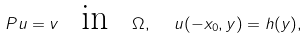<formula> <loc_0><loc_0><loc_500><loc_500>P u = v \text { } \text { in } \text { } \Omega , \text { } \text { } u ( - x _ { 0 } , y ) = h ( y ) ,</formula> 